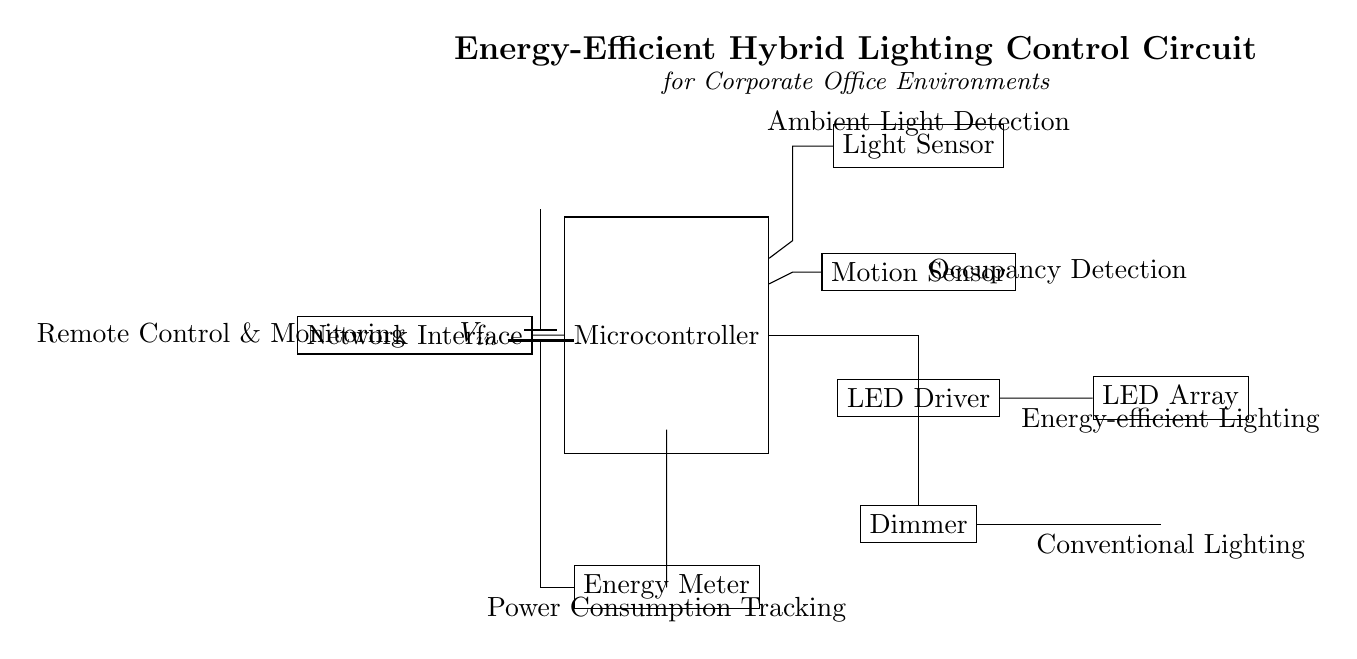What is the role of the microcontroller in this circuit? The microcontroller processes inputs from the light and motion sensors, controlling the LED driver and dimmer based on the detected ambient light and occupancy.
Answer: Control component What type of lighting does the LED driver control? The LED driver controls the LED array, which provides energy-efficient lighting in the office environment.
Answer: Energy-efficient lighting What is the function of the energy meter in this circuit? The energy meter tracks power consumption from the entire circuit, providing data for monitoring energy efficiency and usage.
Answer: Power consumption tracking How does the network interface contribute to the circuit? The network interface allows remote control and monitoring of the lighting system, enabling users to manage energy usage and lighting settings from a distance.
Answer: Remote control and monitoring Which component is responsible for dimming the traditional light? The dimmer controls the brightness of the traditional lamp, enabling adjustment based on occupancy and ambient light levels, enhancing energy efficiency.
Answer: Dimmer How many sensors are present in this circuit? There are two sensors: a light sensor and a motion sensor, which help optimize lighting conditions based on environmental factors.
Answer: Two sensors What does the light sensor detect in this circuit? The light sensor detects ambient light levels, informing the microcontroller whether to adjust the lighting to maintain an appropriate brightness in the office.
Answer: Ambient light detection 